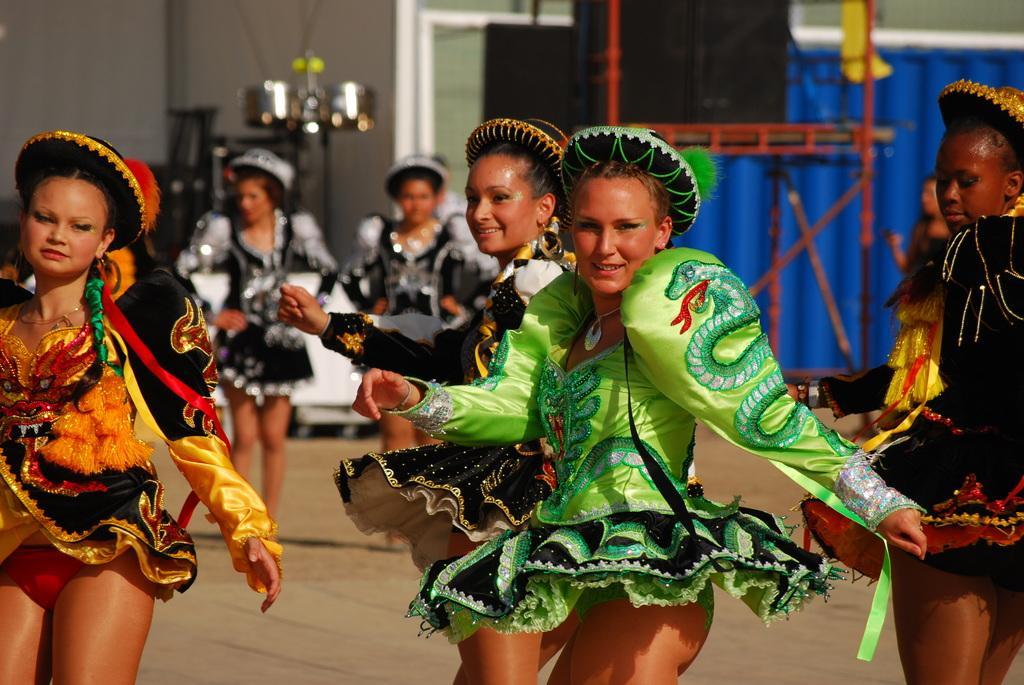Can you describe this image briefly? This image is taken outdoors. In the background there is a building. There is a curtain. There are a few musical instruments. There is a metal stand. In the middle of the image a few women are performing. At the bottom of the image there is a floor. 